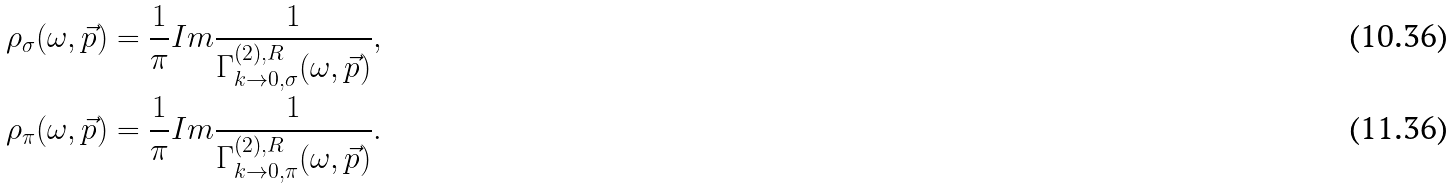Convert formula to latex. <formula><loc_0><loc_0><loc_500><loc_500>\rho _ { \sigma } ( \omega , \vec { p } ) & = \frac { 1 } { \pi } I m \frac { 1 } { \Gamma ^ { ( 2 ) , R } _ { k \rightarrow 0 , \sigma } ( \omega , \vec { p } ) } , \\ \rho _ { \pi } ( \omega , \vec { p } ) & = \frac { 1 } { \pi } I m \frac { 1 } { \Gamma ^ { ( 2 ) , R } _ { k \rightarrow 0 , \pi } ( \omega , \vec { p } ) } .</formula> 